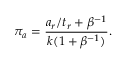Convert formula to latex. <formula><loc_0><loc_0><loc_500><loc_500>\pi _ { a } = \frac { a _ { r } / t _ { r } + \beta ^ { - 1 } } { k ( 1 + \beta ^ { - 1 } ) } .</formula> 